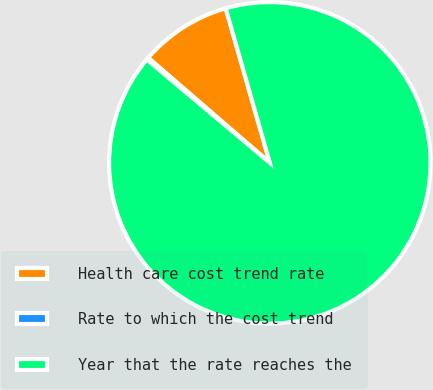Convert chart. <chart><loc_0><loc_0><loc_500><loc_500><pie_chart><fcel>Health care cost trend rate<fcel>Rate to which the cost trend<fcel>Year that the rate reaches the<nl><fcel>9.24%<fcel>0.21%<fcel>90.54%<nl></chart> 